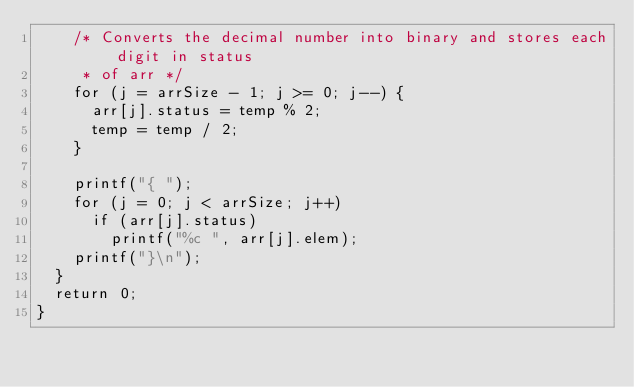<code> <loc_0><loc_0><loc_500><loc_500><_C_>    /* Converts the decimal number into binary and stores each digit in status
     * of arr */
    for (j = arrSize - 1; j >= 0; j--) {
      arr[j].status = temp % 2;
      temp = temp / 2;
    }

    printf("{ ");
    for (j = 0; j < arrSize; j++)
      if (arr[j].status)
        printf("%c ", arr[j].elem);
    printf("}\n");
  }
  return 0;
}
</code> 